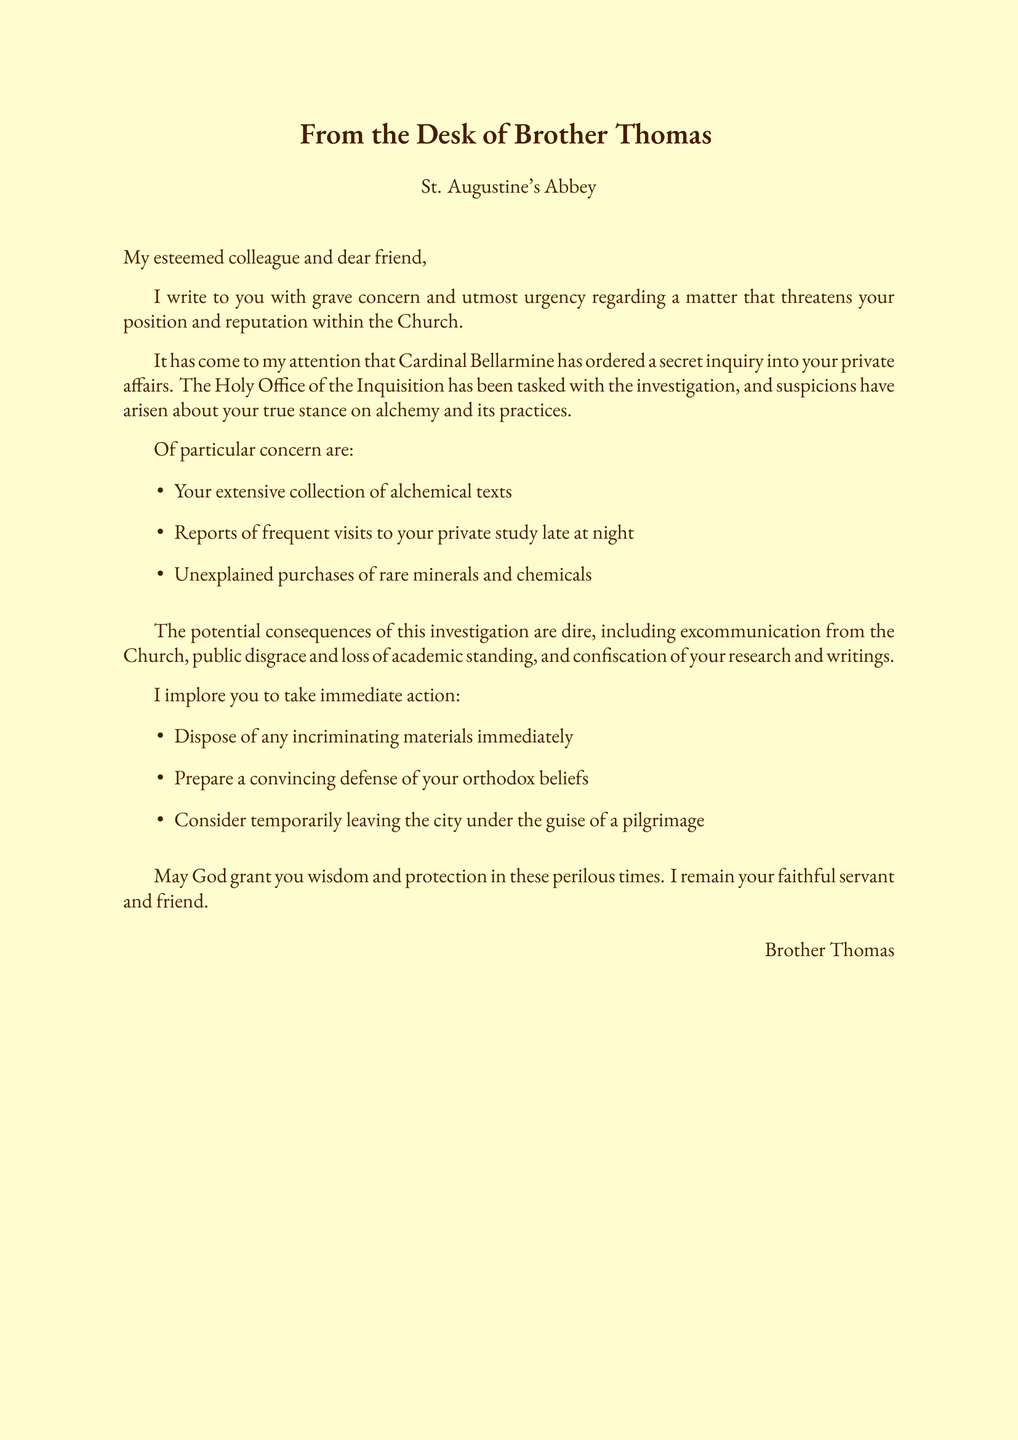What is the name of the sender? The sender's name is mentioned in the signature at the end of the letter.
Answer: Brother Thomas Who ordered the secret inquiry? The document states who ordered the inquiry in the second paragraph.
Answer: Cardinal Bellarmine What is the name of the investigation body? The document specifies the body tasked with the investigation.
Answer: The Holy Office of the Inquisition What type of materials should be disposed of? The advice section details what to dispose of.
Answer: Incriminating materials What are the potential consequences mentioned? The document lists potential consequences in a numbered manner.
Answer: Excommunication from the Church What should be prepared as a defense? The advice section specifies what should be prepared in response to the investigation.
Answer: A convincing defense of your orthodox beliefs What is one suspicious activity noted in the document? The document lists suspicious activities related to the investigation.
Answer: Visits to your private study late at night What could be a reason for temporarily leaving the city? The advice section suggests a reason for leaving the city.
Answer: Under the guise of a pilgrimage 